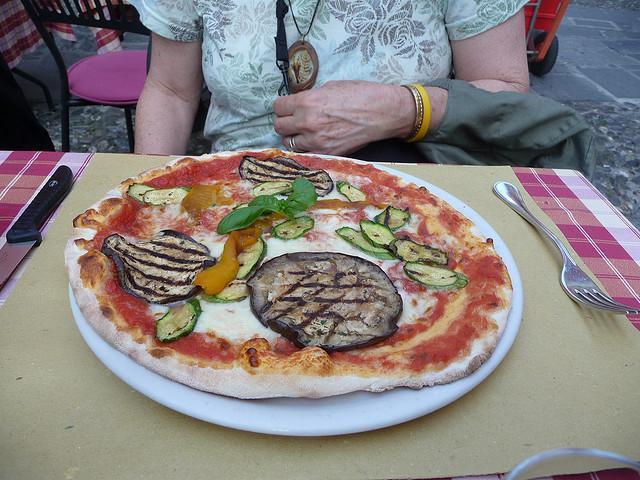Verify the accuracy of this image caption: "The person is touching the pizza.".
Answer yes or no. No. 